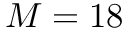Convert formula to latex. <formula><loc_0><loc_0><loc_500><loc_500>M = 1 8</formula> 